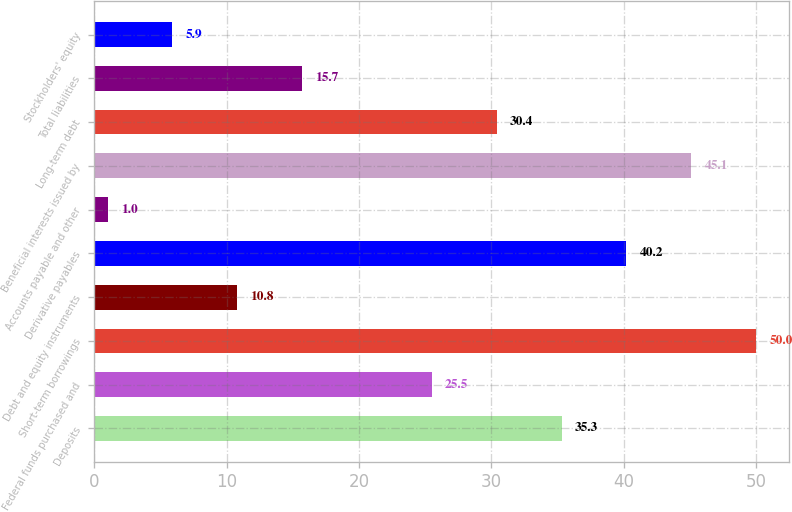Convert chart. <chart><loc_0><loc_0><loc_500><loc_500><bar_chart><fcel>Deposits<fcel>Federal funds purchased and<fcel>Short-term borrowings<fcel>Debt and equity instruments<fcel>Derivative payables<fcel>Accounts payable and other<fcel>Beneficial interests issued by<fcel>Long-term debt<fcel>Total liabilities<fcel>Stockholders' equity<nl><fcel>35.3<fcel>25.5<fcel>50<fcel>10.8<fcel>40.2<fcel>1<fcel>45.1<fcel>30.4<fcel>15.7<fcel>5.9<nl></chart> 